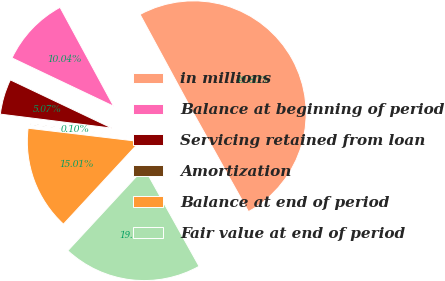<chart> <loc_0><loc_0><loc_500><loc_500><pie_chart><fcel>in millions<fcel>Balance at beginning of period<fcel>Servicing retained from loan<fcel>Amortization<fcel>Balance at end of period<fcel>Fair value at end of period<nl><fcel>49.8%<fcel>10.04%<fcel>5.07%<fcel>0.1%<fcel>15.01%<fcel>19.98%<nl></chart> 